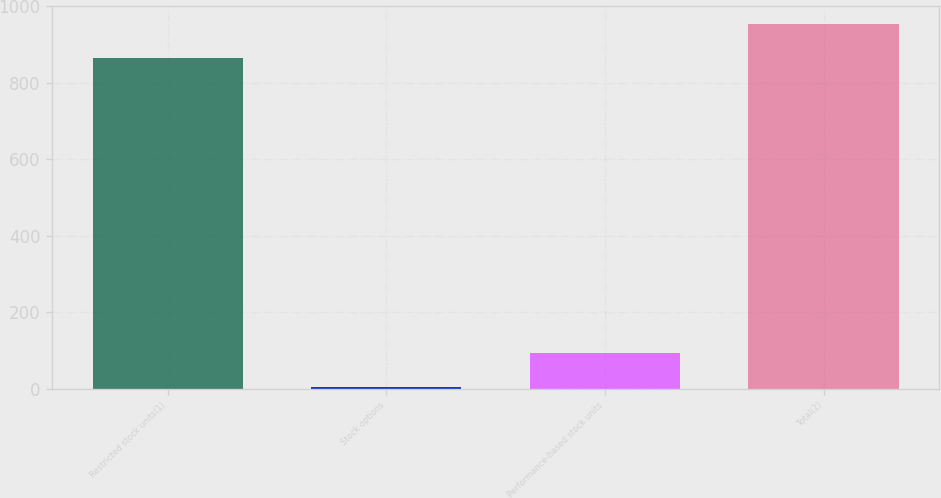<chart> <loc_0><loc_0><loc_500><loc_500><bar_chart><fcel>Restricted stock units(1)<fcel>Stock options<fcel>Performance-based stock units<fcel>Total(2)<nl><fcel>864<fcel>4<fcel>93.3<fcel>953.3<nl></chart> 